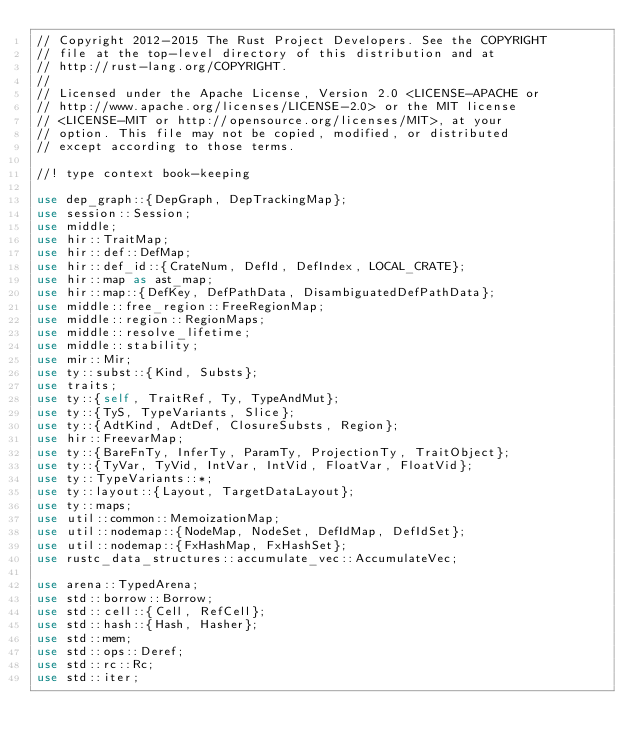Convert code to text. <code><loc_0><loc_0><loc_500><loc_500><_Rust_>// Copyright 2012-2015 The Rust Project Developers. See the COPYRIGHT
// file at the top-level directory of this distribution and at
// http://rust-lang.org/COPYRIGHT.
//
// Licensed under the Apache License, Version 2.0 <LICENSE-APACHE or
// http://www.apache.org/licenses/LICENSE-2.0> or the MIT license
// <LICENSE-MIT or http://opensource.org/licenses/MIT>, at your
// option. This file may not be copied, modified, or distributed
// except according to those terms.

//! type context book-keeping

use dep_graph::{DepGraph, DepTrackingMap};
use session::Session;
use middle;
use hir::TraitMap;
use hir::def::DefMap;
use hir::def_id::{CrateNum, DefId, DefIndex, LOCAL_CRATE};
use hir::map as ast_map;
use hir::map::{DefKey, DefPathData, DisambiguatedDefPathData};
use middle::free_region::FreeRegionMap;
use middle::region::RegionMaps;
use middle::resolve_lifetime;
use middle::stability;
use mir::Mir;
use ty::subst::{Kind, Substs};
use traits;
use ty::{self, TraitRef, Ty, TypeAndMut};
use ty::{TyS, TypeVariants, Slice};
use ty::{AdtKind, AdtDef, ClosureSubsts, Region};
use hir::FreevarMap;
use ty::{BareFnTy, InferTy, ParamTy, ProjectionTy, TraitObject};
use ty::{TyVar, TyVid, IntVar, IntVid, FloatVar, FloatVid};
use ty::TypeVariants::*;
use ty::layout::{Layout, TargetDataLayout};
use ty::maps;
use util::common::MemoizationMap;
use util::nodemap::{NodeMap, NodeSet, DefIdMap, DefIdSet};
use util::nodemap::{FxHashMap, FxHashSet};
use rustc_data_structures::accumulate_vec::AccumulateVec;

use arena::TypedArena;
use std::borrow::Borrow;
use std::cell::{Cell, RefCell};
use std::hash::{Hash, Hasher};
use std::mem;
use std::ops::Deref;
use std::rc::Rc;
use std::iter;</code> 